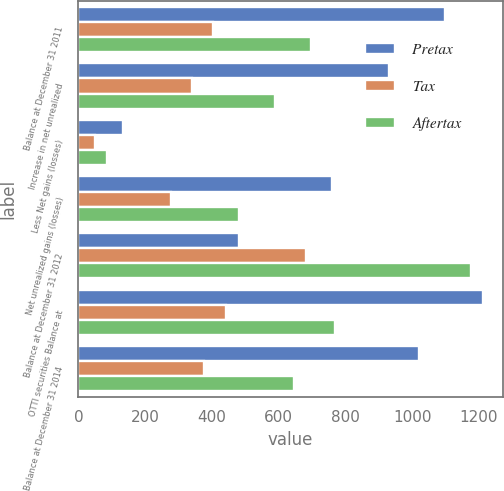<chart> <loc_0><loc_0><loc_500><loc_500><stacked_bar_chart><ecel><fcel>Balance at December 31 2011<fcel>Increase in net unrealized<fcel>Less Net gains (losses)<fcel>Net unrealized gains (losses)<fcel>Balance at December 31 2012<fcel>OTTI securities Balance at<fcel>Balance at December 31 2014<nl><fcel>Pretax<fcel>1098<fcel>931<fcel>134<fcel>760<fcel>481<fcel>1211<fcel>1022<nl><fcel>Tax<fcel>402<fcel>341<fcel>49<fcel>279<fcel>681<fcel>443<fcel>375<nl><fcel>Aftertax<fcel>696<fcel>590<fcel>85<fcel>481<fcel>1177<fcel>768<fcel>647<nl></chart> 